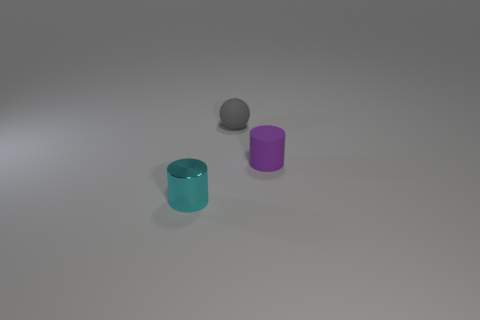What number of things are either small metallic cylinders or purple matte objects? There are a total of three objects in the image: one appears to be a small grey metallic cylinder, and the other two are objects with a matte finish, one of which is purple. So the number of items that are either small metallic cylinders or purple matte objects is three. 